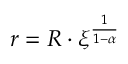Convert formula to latex. <formula><loc_0><loc_0><loc_500><loc_500>r = R \cdot \xi ^ { \frac { 1 } { 1 - \alpha } }</formula> 